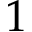Convert formula to latex. <formula><loc_0><loc_0><loc_500><loc_500>1</formula> 